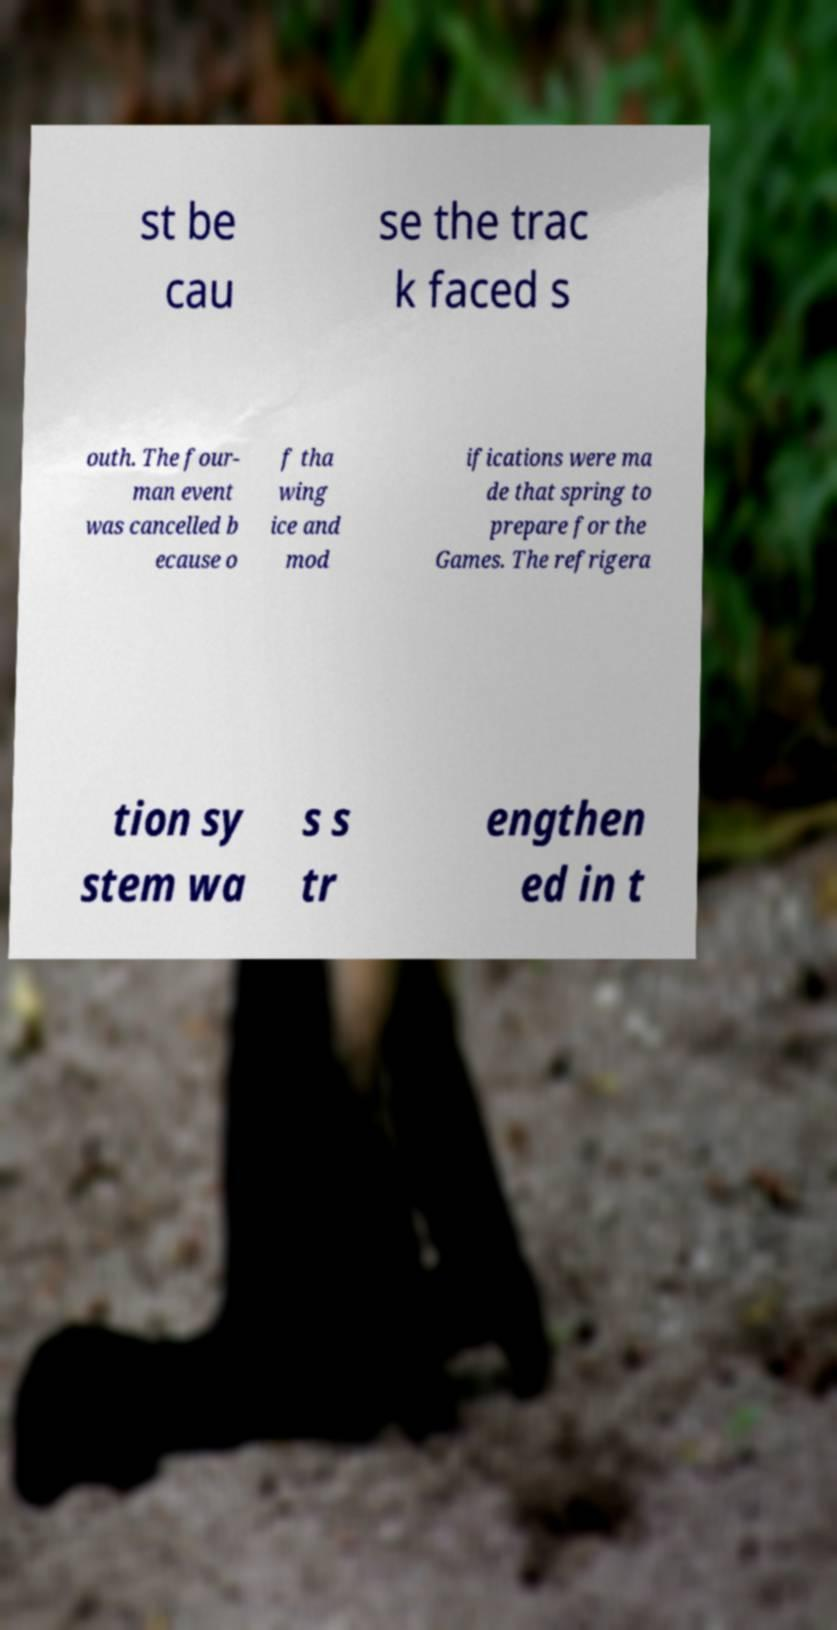Could you assist in decoding the text presented in this image and type it out clearly? st be cau se the trac k faced s outh. The four- man event was cancelled b ecause o f tha wing ice and mod ifications were ma de that spring to prepare for the Games. The refrigera tion sy stem wa s s tr engthen ed in t 